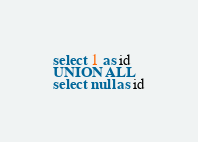<code> <loc_0><loc_0><loc_500><loc_500><_SQL_>select 1 as id
UNION ALL
select null as id</code> 